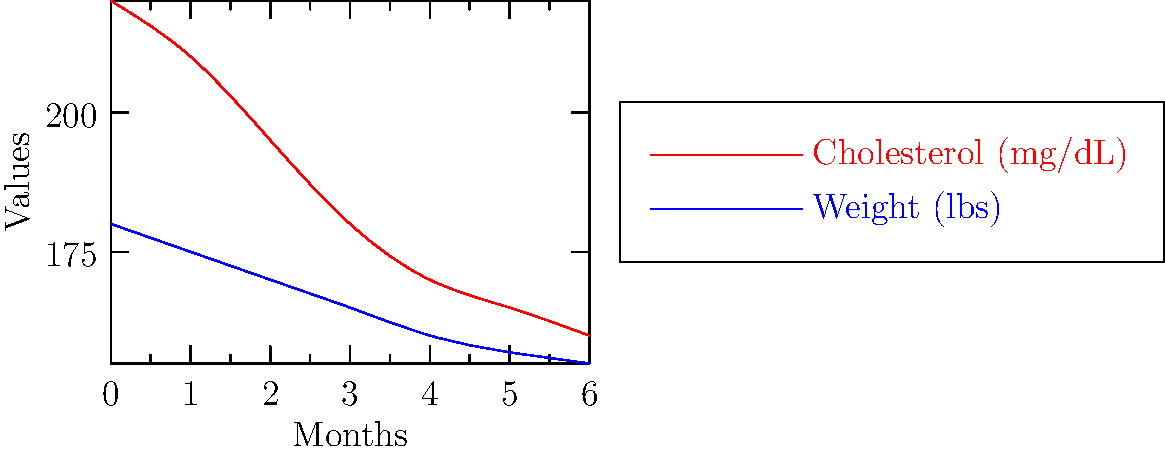Based on the line graph showing changes in cholesterol levels and weight over 6 months after adopting a plant-based diet, what is the percentage decrease in cholesterol from the initial reading to the final reading? To calculate the percentage decrease in cholesterol:

1. Identify initial cholesterol level: 220 mg/dL (at month 0)
2. Identify final cholesterol level: 160 mg/dL (at month 6)
3. Calculate the difference: 220 - 160 = 60 mg/dL
4. Calculate the percentage decrease:
   $\text{Percentage decrease} = \frac{\text{Decrease}}{\text{Initial value}} \times 100\%$
   $= \frac{60}{220} \times 100\% = 0.2727 \times 100\% = 27.27\%$

5. Round to the nearest whole number: 27%

The cholesterol level decreased by approximately 27% over the 6-month period.
Answer: 27% 